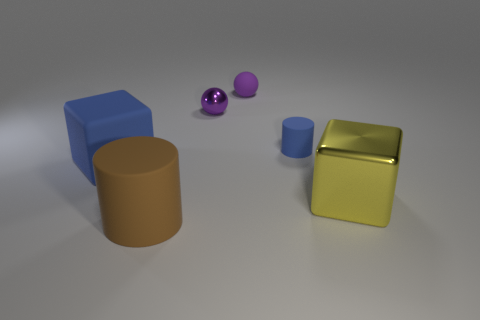What is the color of the other object that is the same shape as the large yellow metal thing?
Give a very brief answer. Blue. What material is the thing that is in front of the tiny purple shiny thing and behind the big rubber block?
Give a very brief answer. Rubber. Do the brown thing to the left of the small blue matte cylinder and the cube that is to the left of the tiny cylinder have the same material?
Your answer should be very brief. Yes. The brown matte thing is what size?
Give a very brief answer. Large. What is the size of the rubber object that is the same shape as the yellow metal thing?
Offer a terse response. Large. How many large brown cylinders are behind the small metal thing?
Ensure brevity in your answer.  0. What color is the metal thing that is in front of the tiny ball in front of the purple rubber ball?
Your answer should be compact. Yellow. Is there any other thing that has the same shape as the large blue thing?
Provide a succinct answer. Yes. Are there the same number of matte spheres that are left of the purple metal ball and brown objects that are on the right side of the shiny cube?
Make the answer very short. Yes. How many blocks are either small blue matte things or big blue objects?
Your answer should be compact. 1. 